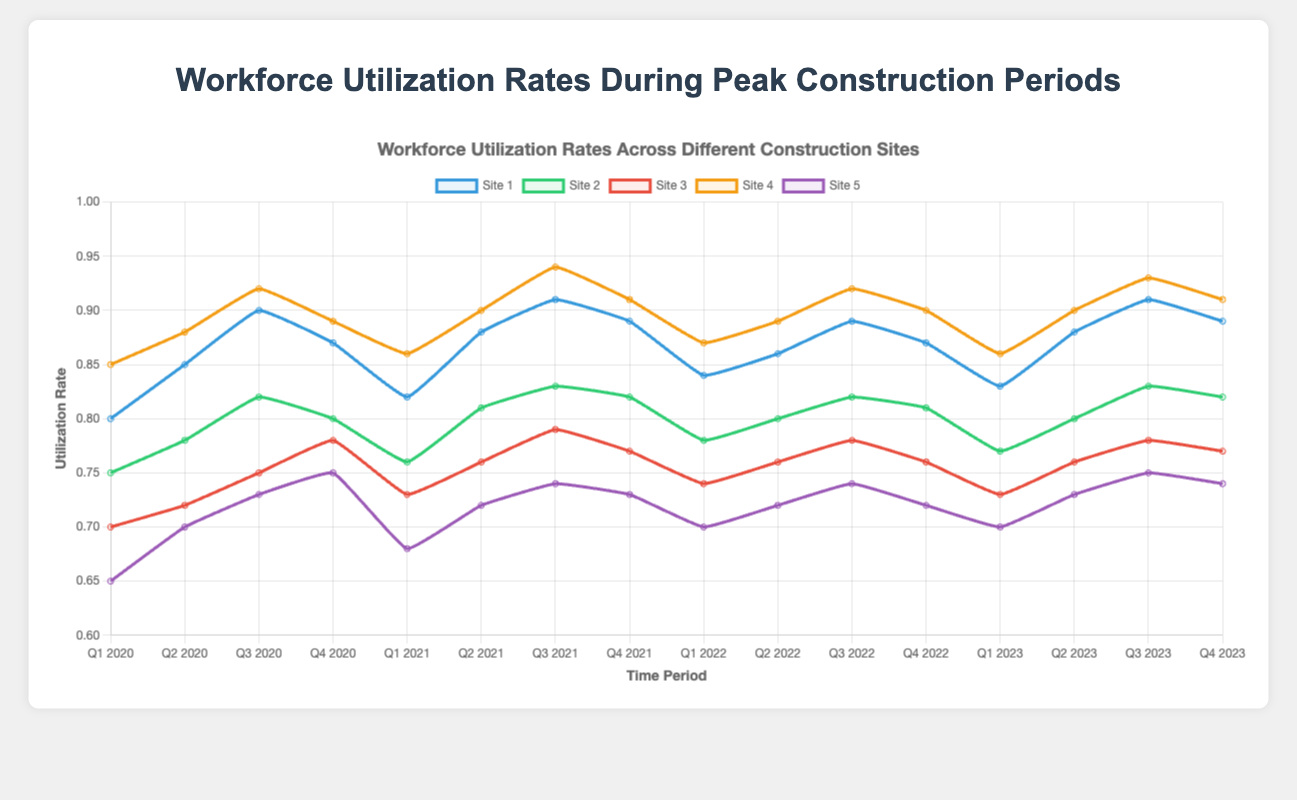What is the difference in utilization rates between Site 1 and Site 2 in Q3 2020? In Q3 2020, Site 1 has a utilization rate of 0.90, and Site 2 has a rate of 0.82. The difference is calculated as 0.90 - 0.82 = 0.08.
Answer: 0.08 Which site had the highest utilization rate in Q3 2021? In Q3 2021, the utilization rates are Site 1 (0.91), Site 2 (0.83), Site 3 (0.79), Site 4 (0.94), and Site 5 (0.74). Site 4 has the highest utilization rate of 0.94.
Answer: Site 4 What is the average utilization rate of Site 3 for the entire 2022? The utilization rates for Site 3 in 2022 are: Q1 (0.74), Q2 (0.76), Q3 (0.78), and Q4 (0.76). The average rate is calculated as (0.74 + 0.76 + 0.78 + 0.76) / 4 = 3.04 / 4 = 0.76.
Answer: 0.76 During which quarter did Site 5 have the lowest utilization rate from 2020 to 2023? Reviewing the utilization rates for Site 5 over the given period, the lowest rate is 0.65, occurring in Q1 2020.
Answer: Q1 2020 Which sites had an increase in utilization rate from Q1 2021 to Q2 2021? Comparing Q1 2021 and Q2 2021: Site 1 (0.82 to 0.88), Site 2 (0.76 to 0.81), Site 3 (0.73 to 0.76), Site 4 (0.86 to 0.90), and Site 5 (0.68 to 0.72). All sites showed an increase.
Answer: All sites By how much did Site 4's utilization rate change from Q2 2022 to Q3 2022? Site 4's utilization rate was 0.89 in Q2 2022 and 0.92 in Q3 2022. The change is 0.92 - 0.89 = 0.03.
Answer: 0.03 Which site consistently had utilization rates above 0.8 in every quarter from 2020 to 2023? Reviewing the utilization rates for each site over the entire period shows that Site 4 had rates of 0.85, 0.88, 0.92, 0.89, 0.86, 0.90, 0.94, 0.91, 0.87, 0.89, 0.92, 0.90, 0.86, 0.90, 0.93, and 0.91—all above 0.80.
Answer: Site 4 Which quarter had the highest average utilization rate across all sites in 2020? Averaging the utilization rates across all sites for each quarter in 2020: Q1 (0.75), Q2 (0.786), Q3 (0.824), and Q4 (0.818). Q3 2020 had the highest average rate.
Answer: Q3 2020 